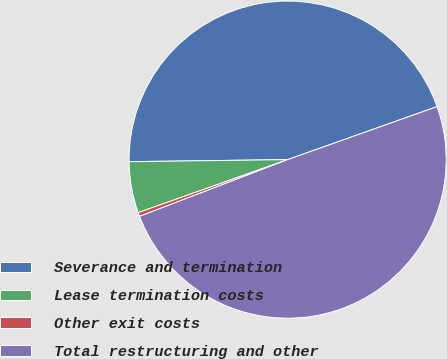Convert chart to OTSL. <chart><loc_0><loc_0><loc_500><loc_500><pie_chart><fcel>Severance and termination<fcel>Lease termination costs<fcel>Other exit costs<fcel>Total restructuring and other<nl><fcel>44.78%<fcel>5.22%<fcel>0.4%<fcel>49.6%<nl></chart> 